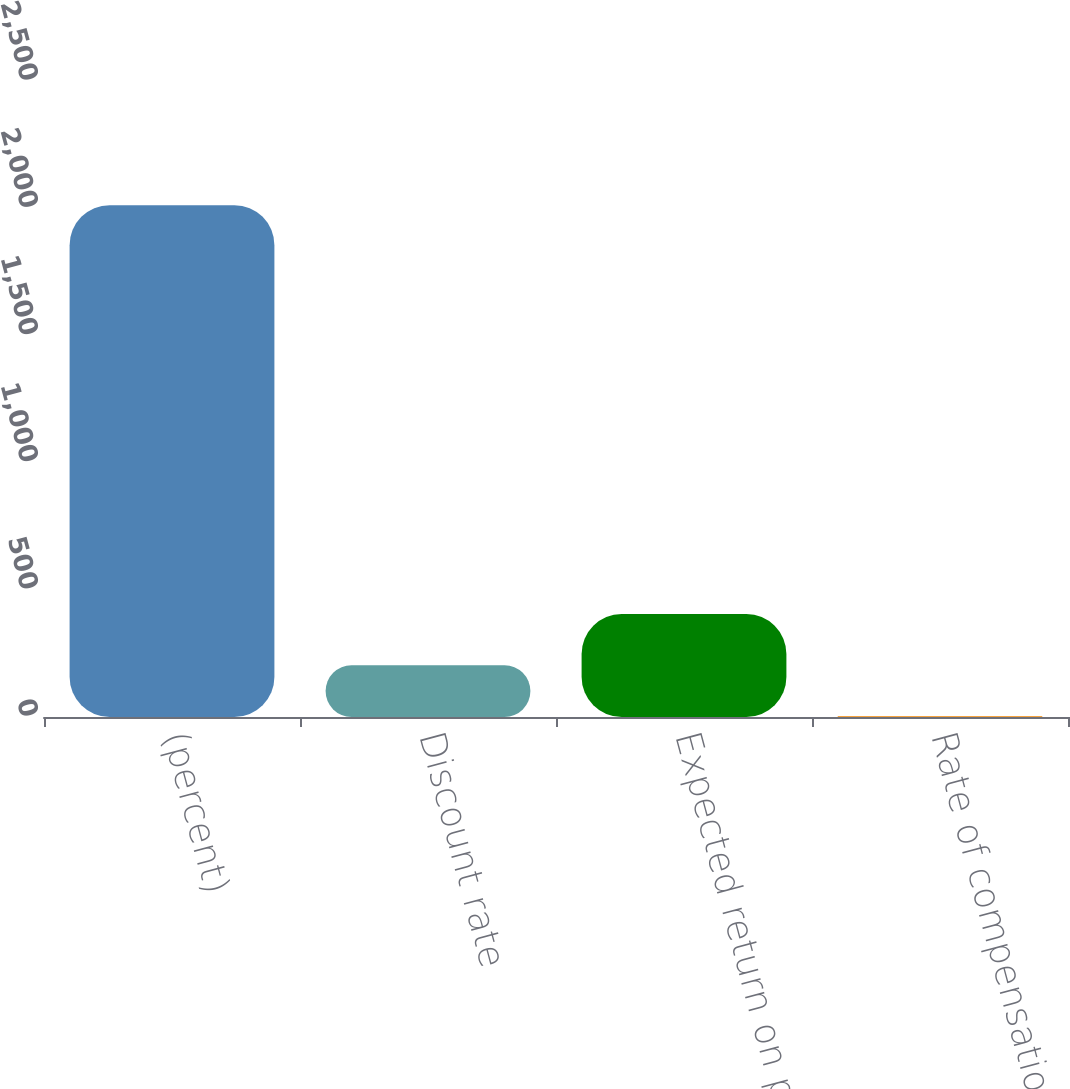Convert chart. <chart><loc_0><loc_0><loc_500><loc_500><bar_chart><fcel>(percent)<fcel>Discount rate<fcel>Expected return on plan assets<fcel>Rate of compensation increase<nl><fcel>2012<fcel>203.7<fcel>404.62<fcel>2.78<nl></chart> 